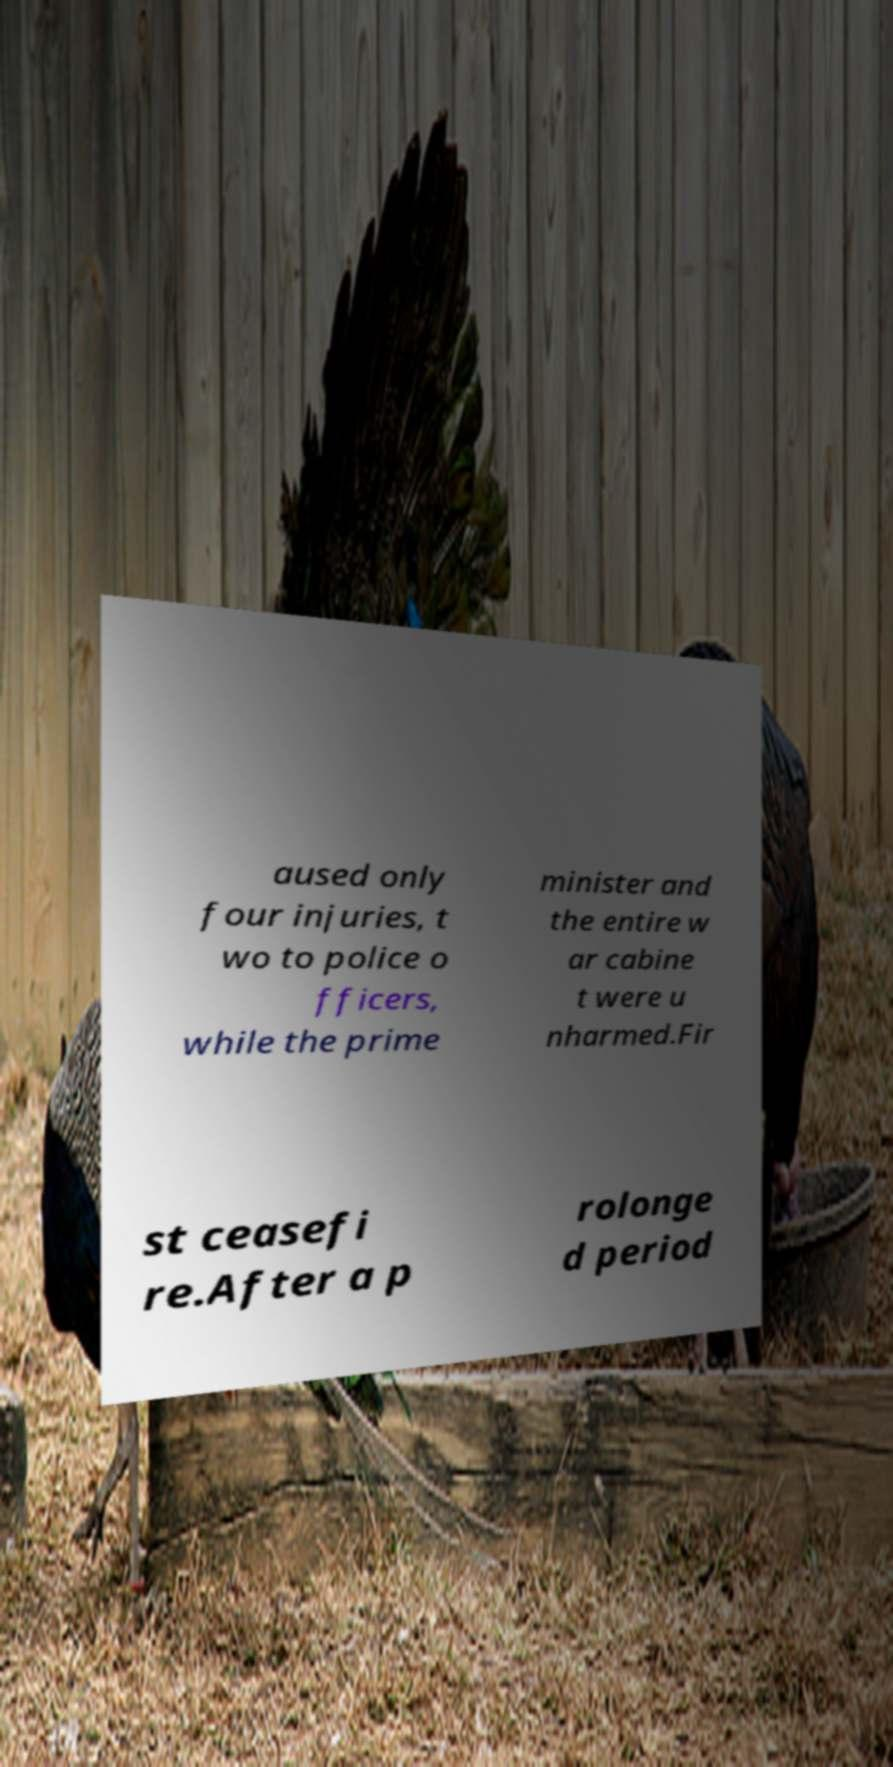Can you accurately transcribe the text from the provided image for me? aused only four injuries, t wo to police o fficers, while the prime minister and the entire w ar cabine t were u nharmed.Fir st ceasefi re.After a p rolonge d period 